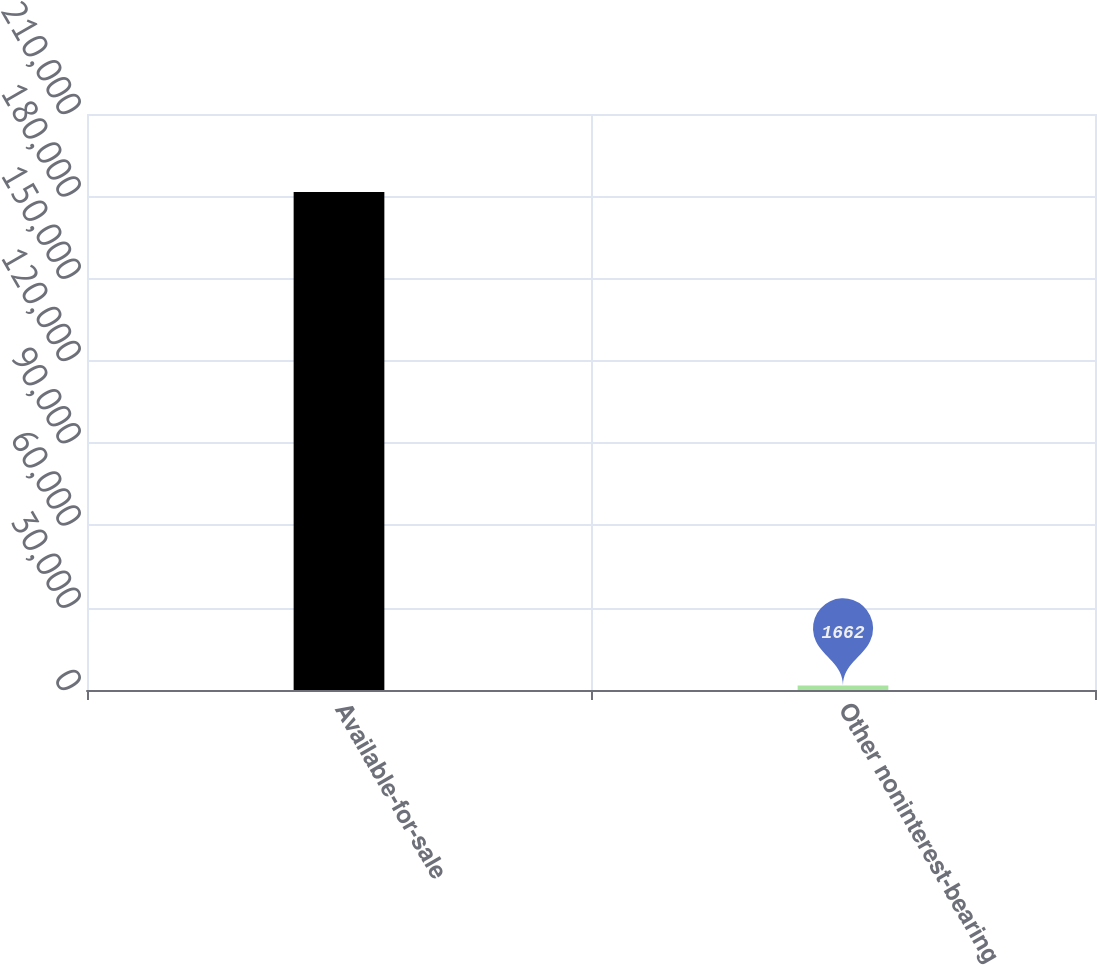Convert chart. <chart><loc_0><loc_0><loc_500><loc_500><bar_chart><fcel>Available-for-sale<fcel>Other noninterest-bearing<nl><fcel>181591<fcel>1662<nl></chart> 